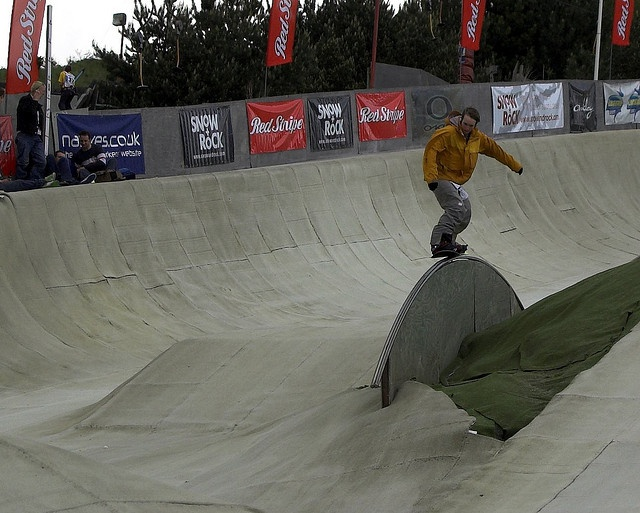Describe the objects in this image and their specific colors. I can see people in white, black, maroon, olive, and gray tones, people in white, black, gray, and maroon tones, people in white, black, gray, and darkgray tones, people in white, black, and gray tones, and people in white, black, gray, darkgray, and olive tones in this image. 